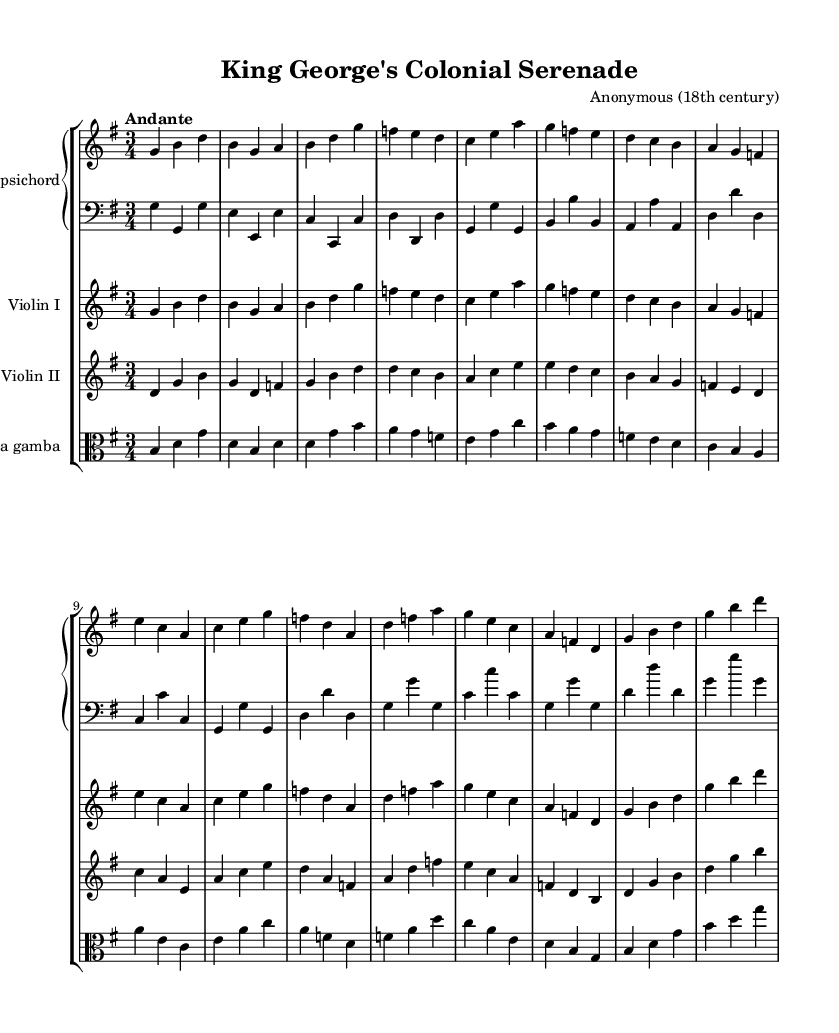What is the key signature of this music? The key signature is G major, which has one sharp (F#). This can be determined by looking at the key signature indicated in the beginning of the score.
Answer: G major What is the time signature of this piece? The time signature is 3/4, which indicates that there are three beats in each measure and the quarter note gets one beat. This information is found at the beginning of the score right after the key signature.
Answer: 3/4 What is the tempo marking for this piece? The tempo marking is "Andante," which indicates a moderate walking pace. This marking appears at the start of the score, suggesting how quickly the piece should be played.
Answer: Andante How many measures are in the first line? There are four measures in the first line. This can be counted by identifying the four vertical bar lines that separate the measures in the staff.
Answer: 4 What is the instrumentation of this score? The instrumentation includes harpsichord, violin I, violin II, and viola da gamba. This information is derived from the title of the instruments listed at the beginning of each staff in the score.
Answer: Harpsichord, Violin I, Violin II, Viola da gamba What is the highest note in the score? The highest note in the score is "g'." This is identified by analyzing the pitches in the staff, specifically the uppermost notes that appear in the treble clef staff.
Answer: g What is the rhythmic pattern of the harpsichord in the first measure? The rhythmic pattern of the harpsichord in the first measure is quarter note, quarter note, quarter note. This can be observed by looking at the note values presented in the first measure of the upper staff for harpsichord.
Answer: Quarter note, Quarter note, Quarter note 